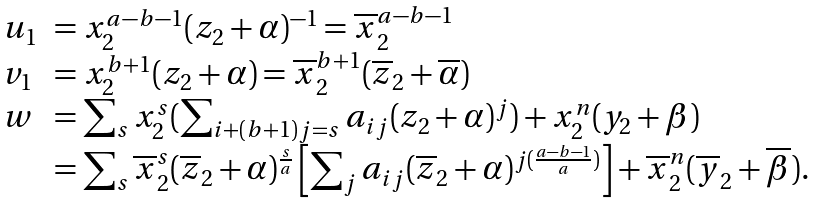Convert formula to latex. <formula><loc_0><loc_0><loc_500><loc_500>\begin{array} { l l } u _ { 1 } & = x _ { 2 } ^ { a - b - 1 } ( z _ { 2 } + \alpha ) ^ { - 1 } = \overline { x } _ { 2 } ^ { a - b - 1 } \\ v _ { 1 } & = x _ { 2 } ^ { b + 1 } ( z _ { 2 } + \alpha ) = \overline { x } _ { 2 } ^ { b + 1 } ( \overline { z } _ { 2 } + \overline { \alpha } ) \\ w & = \sum _ { s } x _ { 2 } ^ { s } ( \sum _ { i + ( b + 1 ) j = s } a _ { i j } ( z _ { 2 } + \alpha ) ^ { j } ) + x _ { 2 } ^ { n } ( y _ { 2 } + \beta ) \\ & = \sum _ { s } \overline { x } _ { 2 } ^ { s } ( \overline { z } _ { 2 } + \alpha ) ^ { \frac { s } { a } } \left [ \sum _ { j } a _ { i j } ( \overline { z } _ { 2 } + \alpha ) ^ { j ( \frac { a - b - 1 } { a } ) } \right ] + \overline { x } _ { 2 } ^ { n } ( \overline { y } _ { 2 } + \overline { \beta } ) . \end{array}</formula> 